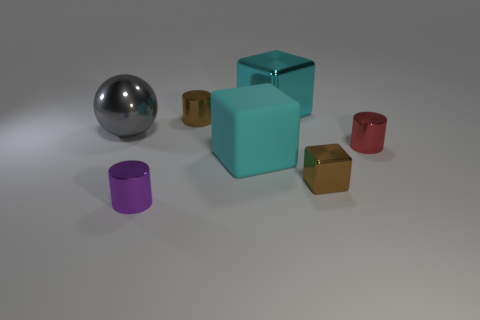How many blue objects are either big shiny things or large matte objects?
Offer a very short reply. 0. How many other objects are the same shape as the small red thing?
Provide a succinct answer. 2. What is the shape of the tiny object that is to the left of the brown block and behind the brown metallic cube?
Keep it short and to the point. Cylinder. There is a tiny purple shiny thing; are there any large cyan matte blocks in front of it?
Offer a terse response. No. The other cyan thing that is the same shape as the large cyan matte object is what size?
Ensure brevity in your answer.  Large. Are there any other things that are the same size as the gray metallic object?
Provide a succinct answer. Yes. Do the cyan rubber object and the red metal object have the same shape?
Your answer should be compact. No. There is a brown object on the left side of the big cyan block behind the small brown metal cylinder; what size is it?
Keep it short and to the point. Small. What color is the rubber thing that is the same shape as the large cyan metallic thing?
Provide a short and direct response. Cyan. How many matte blocks have the same color as the shiny ball?
Offer a very short reply. 0. 